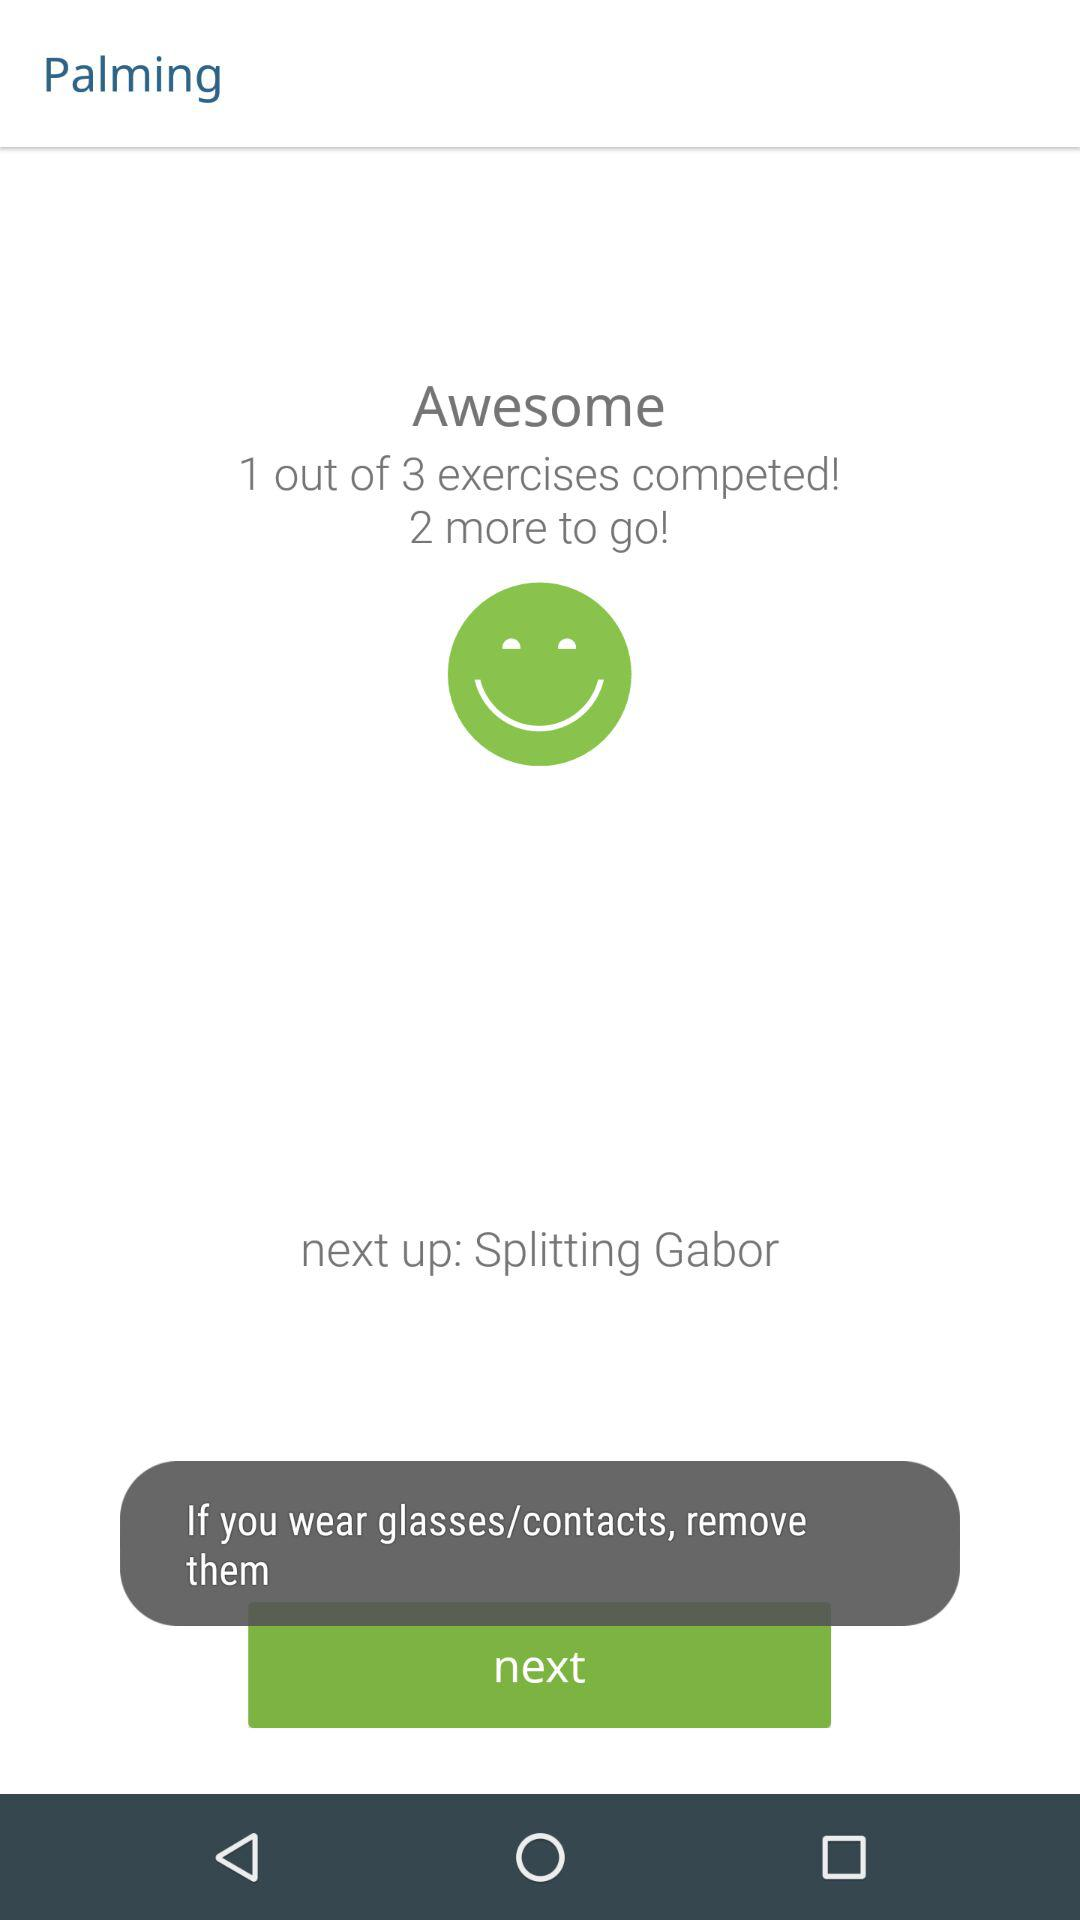What type of exercise is being done?
When the provided information is insufficient, respond with <no answer>. <no answer> 